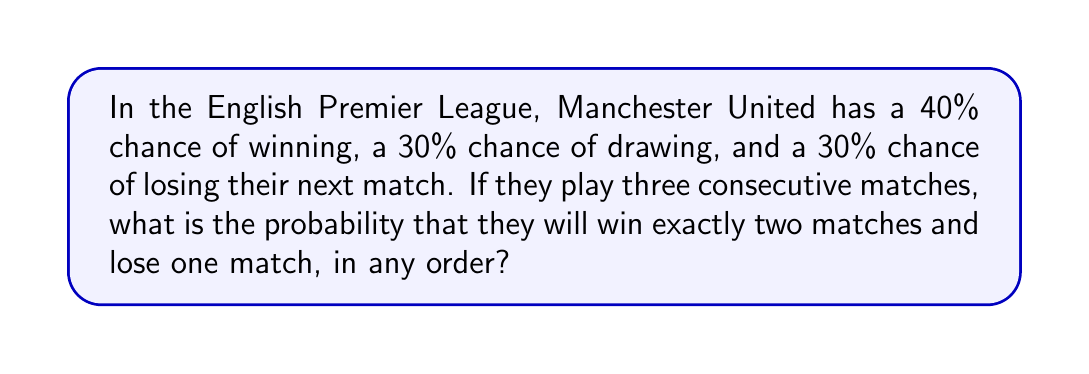Show me your answer to this math problem. Let's approach this step-by-step:

1) First, we need to recognize that this is a binomial probability problem with a twist. We're looking for exactly two wins and one loss, which means no draws.

2) The probability of winning a single match is 0.4, and the probability of losing is 0.3.

3) We need to calculate the probability of getting 2 wins and 1 loss in any order out of 3 matches. This can happen in 3 ways:
   - Win, Win, Lose
   - Win, Lose, Win
   - Lose, Win, Win

4) The probability of each of these specific outcomes is:

   $P(\text{W,W,L}) = P(\text{W,L,W}) = P(\text{L,W,W}) = 0.4 \times 0.4 \times 0.3 = 0.048$

5) Since we want the probability of any of these outcomes occurring, we sum their individual probabilities:

   $P(\text{2 wins and 1 loss}) = 0.048 + 0.048 + 0.048 = 0.144$

6) We can also calculate this using the combination formula:

   $$P(\text{2 wins and 1 loss}) = \binom{3}{2} \times 0.4^2 \times 0.3^1 = 3 \times 0.16 \times 0.3 = 0.144$$

   Where $\binom{3}{2} = 3$ is the number of ways to choose 2 wins from 3 matches.
Answer: 0.144 